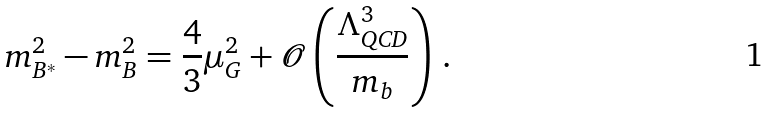Convert formula to latex. <formula><loc_0><loc_0><loc_500><loc_500>m _ { B ^ { * } } ^ { 2 } - m _ { B } ^ { 2 } = \frac { 4 } { 3 } \mu _ { G } ^ { 2 } + \mathcal { O } \left ( \frac { \Lambda _ { \text {QCD} } ^ { 3 } } { m _ { b } } \right ) \, .</formula> 